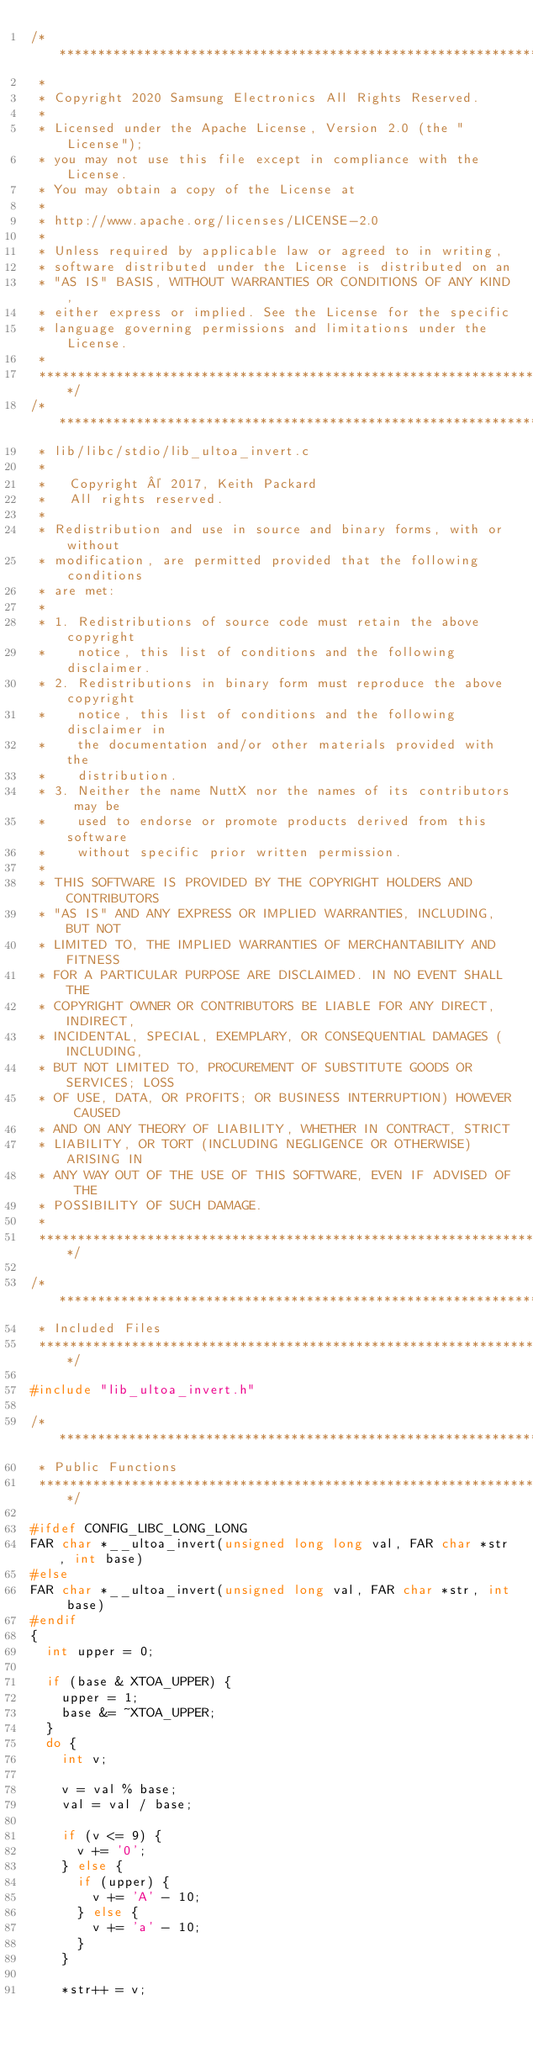<code> <loc_0><loc_0><loc_500><loc_500><_C_>/****************************************************************************
 *
 * Copyright 2020 Samsung Electronics All Rights Reserved.
 *
 * Licensed under the Apache License, Version 2.0 (the "License");
 * you may not use this file except in compliance with the License.
 * You may obtain a copy of the License at
 *
 * http://www.apache.org/licenses/LICENSE-2.0
 *
 * Unless required by applicable law or agreed to in writing,
 * software distributed under the License is distributed on an
 * "AS IS" BASIS, WITHOUT WARRANTIES OR CONDITIONS OF ANY KIND,
 * either express or implied. See the License for the specific
 * language governing permissions and limitations under the License.
 *
 ****************************************************************************/
/****************************************************************************
 * lib/libc/stdio/lib_ultoa_invert.c
 *
 *   Copyright © 2017, Keith Packard
 *   All rights reserved.
 *
 * Redistribution and use in source and binary forms, with or without
 * modification, are permitted provided that the following conditions
 * are met:
 *
 * 1. Redistributions of source code must retain the above copyright
 *    notice, this list of conditions and the following disclaimer.
 * 2. Redistributions in binary form must reproduce the above copyright
 *    notice, this list of conditions and the following disclaimer in
 *    the documentation and/or other materials provided with the
 *    distribution.
 * 3. Neither the name NuttX nor the names of its contributors may be
 *    used to endorse or promote products derived from this software
 *    without specific prior written permission.
 *
 * THIS SOFTWARE IS PROVIDED BY THE COPYRIGHT HOLDERS AND CONTRIBUTORS
 * "AS IS" AND ANY EXPRESS OR IMPLIED WARRANTIES, INCLUDING, BUT NOT
 * LIMITED TO, THE IMPLIED WARRANTIES OF MERCHANTABILITY AND FITNESS
 * FOR A PARTICULAR PURPOSE ARE DISCLAIMED. IN NO EVENT SHALL THE
 * COPYRIGHT OWNER OR CONTRIBUTORS BE LIABLE FOR ANY DIRECT, INDIRECT,
 * INCIDENTAL, SPECIAL, EXEMPLARY, OR CONSEQUENTIAL DAMAGES (INCLUDING,
 * BUT NOT LIMITED TO, PROCUREMENT OF SUBSTITUTE GOODS OR SERVICES; LOSS
 * OF USE, DATA, OR PROFITS; OR BUSINESS INTERRUPTION) HOWEVER CAUSED
 * AND ON ANY THEORY OF LIABILITY, WHETHER IN CONTRACT, STRICT
 * LIABILITY, OR TORT (INCLUDING NEGLIGENCE OR OTHERWISE) ARISING IN
 * ANY WAY OUT OF THE USE OF THIS SOFTWARE, EVEN IF ADVISED OF THE
 * POSSIBILITY OF SUCH DAMAGE.
 *
 ****************************************************************************/

/****************************************************************************
 * Included Files
 ****************************************************************************/

#include "lib_ultoa_invert.h"

/****************************************************************************
 * Public Functions
 ****************************************************************************/

#ifdef CONFIG_LIBC_LONG_LONG
FAR char *__ultoa_invert(unsigned long long val, FAR char *str, int base)
#else
FAR char *__ultoa_invert(unsigned long val, FAR char *str, int base)
#endif
{
	int upper = 0;

	if (base & XTOA_UPPER) {
		upper = 1;
		base &= ~XTOA_UPPER;
	}
	do {
		int v;

		v = val % base;
		val = val / base;

		if (v <= 9) {
			v += '0';
		} else {
			if (upper) {
				v += 'A' - 10;
			} else {
				v += 'a' - 10;
			}
		}

		*str++ = v;</code> 